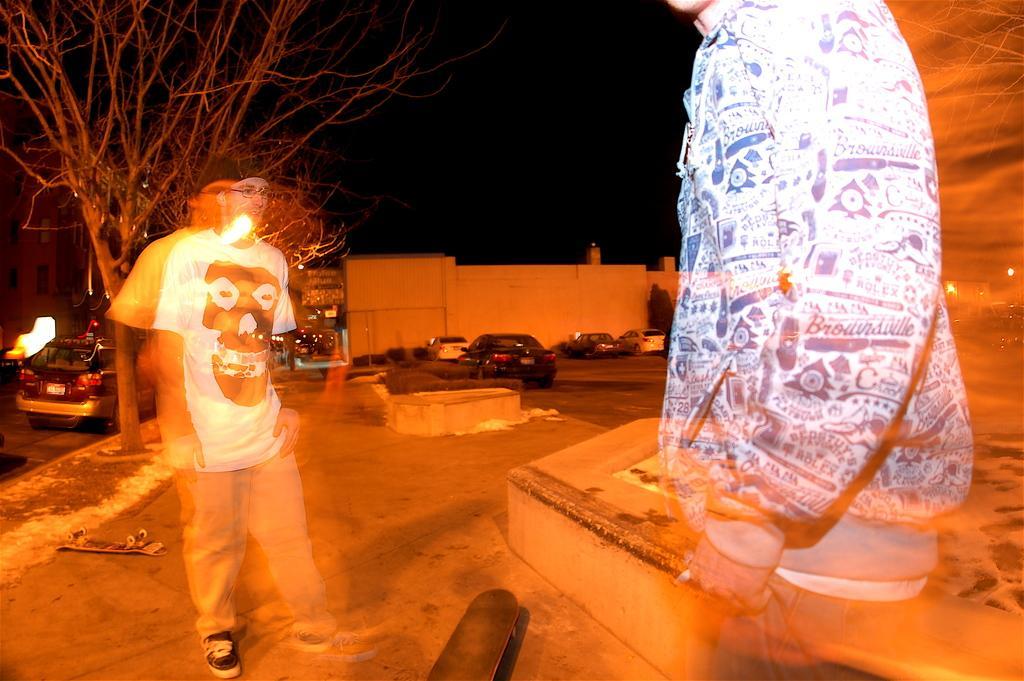In one or two sentences, can you explain what this image depicts? In the foreground of this image, there are people standing whose images are blur. At the bottom, there is a skateboard and behind them, there is a skateboard, few plants, vehicles, trees, a vehicle on the road, buildings and the dark sky. 